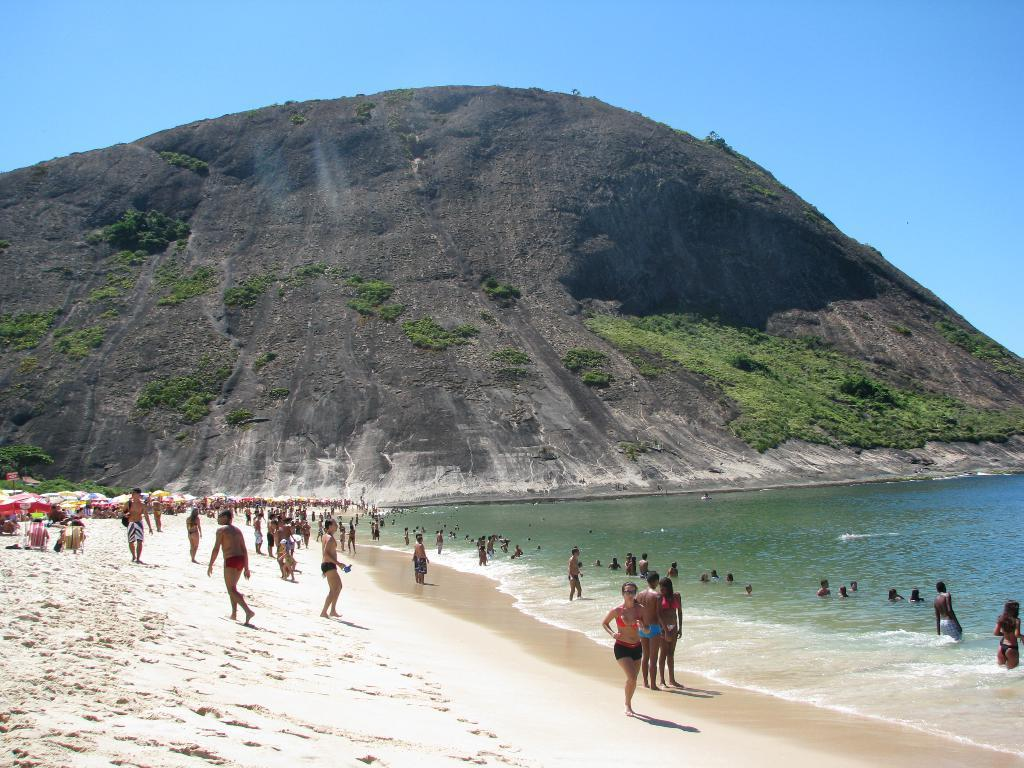What are the people near the sea shore doing? Some people are standing near the sea shore, while others are swimming in the sea. Can you describe the background of the image? There is a rock hill in the background. What is there any theories being discussed by the people near the sea shore in the image? There is no indication in the image that the people are discussing any theories. 